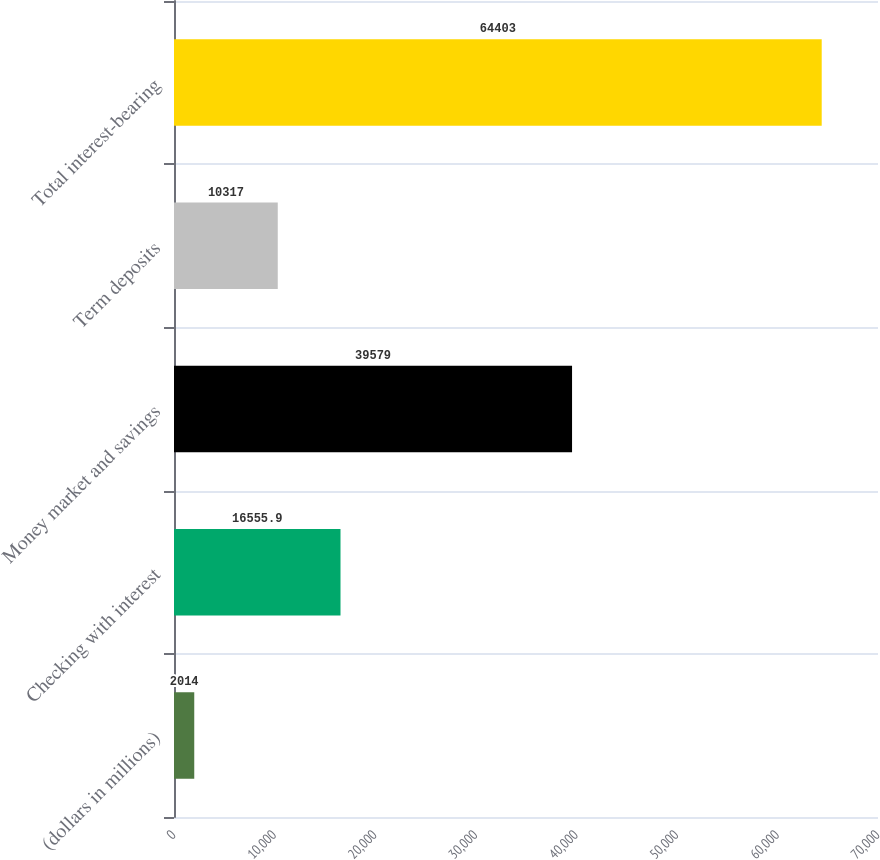Convert chart to OTSL. <chart><loc_0><loc_0><loc_500><loc_500><bar_chart><fcel>(dollars in millions)<fcel>Checking with interest<fcel>Money market and savings<fcel>Term deposits<fcel>Total interest-bearing<nl><fcel>2014<fcel>16555.9<fcel>39579<fcel>10317<fcel>64403<nl></chart> 